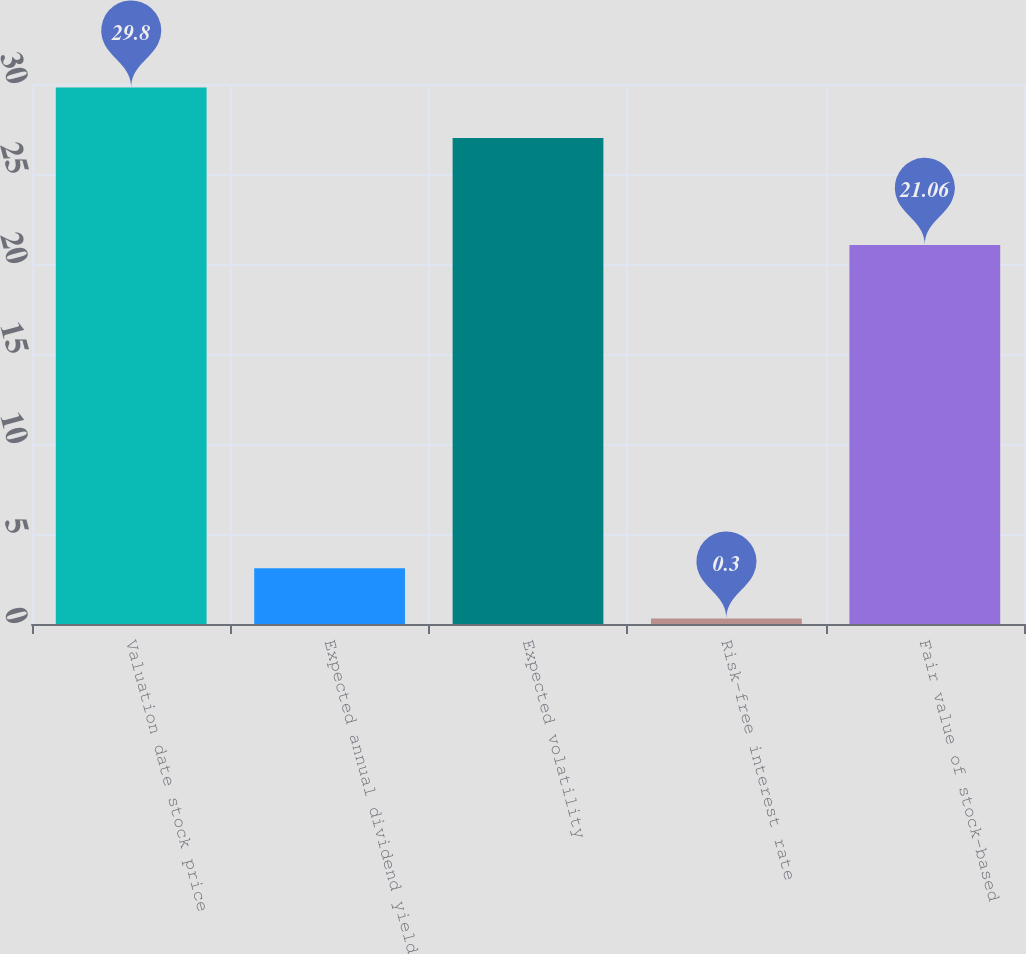Convert chart. <chart><loc_0><loc_0><loc_500><loc_500><bar_chart><fcel>Valuation date stock price<fcel>Expected annual dividend yield<fcel>Expected volatility<fcel>Risk-free interest rate<fcel>Fair value of stock-based<nl><fcel>29.8<fcel>3.1<fcel>27<fcel>0.3<fcel>21.06<nl></chart> 